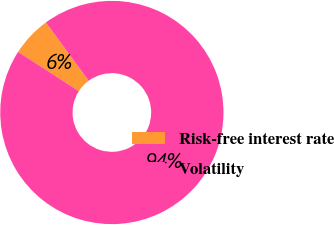Convert chart to OTSL. <chart><loc_0><loc_0><loc_500><loc_500><pie_chart><fcel>Risk-free interest rate<fcel>Volatility<nl><fcel>5.8%<fcel>94.2%<nl></chart> 